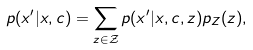Convert formula to latex. <formula><loc_0><loc_0><loc_500><loc_500>p ( x ^ { \prime } | x , c ) = \sum _ { z \in \mathcal { Z } } p ( x ^ { \prime } | x , c , z ) p _ { Z } ( z ) ,</formula> 